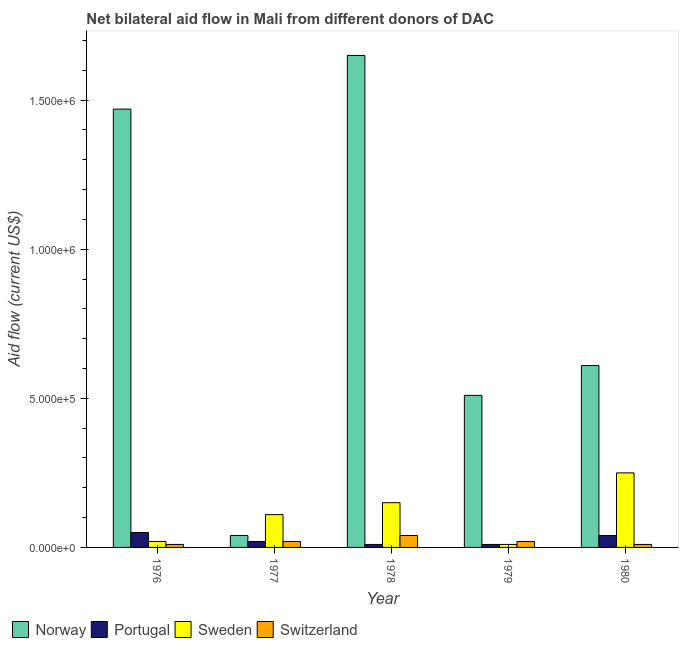How many different coloured bars are there?
Provide a succinct answer. 4. How many groups of bars are there?
Provide a short and direct response. 5. Are the number of bars per tick equal to the number of legend labels?
Provide a short and direct response. Yes. Are the number of bars on each tick of the X-axis equal?
Make the answer very short. Yes. What is the label of the 5th group of bars from the left?
Provide a short and direct response. 1980. In how many cases, is the number of bars for a given year not equal to the number of legend labels?
Offer a terse response. 0. What is the amount of aid given by norway in 1977?
Offer a very short reply. 4.00e+04. Across all years, what is the maximum amount of aid given by norway?
Give a very brief answer. 1.65e+06. Across all years, what is the minimum amount of aid given by switzerland?
Offer a very short reply. 10000. In which year was the amount of aid given by portugal maximum?
Make the answer very short. 1976. In which year was the amount of aid given by switzerland minimum?
Make the answer very short. 1976. What is the total amount of aid given by norway in the graph?
Your answer should be very brief. 4.28e+06. What is the difference between the amount of aid given by norway in 1979 and that in 1980?
Your answer should be compact. -1.00e+05. What is the difference between the amount of aid given by norway in 1976 and the amount of aid given by switzerland in 1977?
Make the answer very short. 1.43e+06. What is the average amount of aid given by portugal per year?
Provide a short and direct response. 2.60e+04. In the year 1979, what is the difference between the amount of aid given by norway and amount of aid given by portugal?
Make the answer very short. 0. In how many years, is the amount of aid given by norway greater than 400000 US$?
Offer a terse response. 4. What is the ratio of the amount of aid given by norway in 1977 to that in 1979?
Offer a terse response. 0.08. Is the amount of aid given by sweden in 1979 less than that in 1980?
Ensure brevity in your answer.  Yes. What is the difference between the highest and the lowest amount of aid given by portugal?
Make the answer very short. 4.00e+04. Is it the case that in every year, the sum of the amount of aid given by sweden and amount of aid given by norway is greater than the sum of amount of aid given by switzerland and amount of aid given by portugal?
Make the answer very short. No. What does the 1st bar from the left in 1980 represents?
Your answer should be very brief. Norway. What does the 1st bar from the right in 1977 represents?
Provide a short and direct response. Switzerland. How many bars are there?
Provide a succinct answer. 20. Are all the bars in the graph horizontal?
Make the answer very short. No. What is the difference between two consecutive major ticks on the Y-axis?
Provide a succinct answer. 5.00e+05. Are the values on the major ticks of Y-axis written in scientific E-notation?
Offer a very short reply. Yes. Does the graph contain grids?
Offer a very short reply. No. How many legend labels are there?
Offer a terse response. 4. What is the title of the graph?
Ensure brevity in your answer.  Net bilateral aid flow in Mali from different donors of DAC. What is the label or title of the Y-axis?
Provide a short and direct response. Aid flow (current US$). What is the Aid flow (current US$) in Norway in 1976?
Provide a short and direct response. 1.47e+06. What is the Aid flow (current US$) of Sweden in 1976?
Your answer should be very brief. 2.00e+04. What is the Aid flow (current US$) in Switzerland in 1976?
Your response must be concise. 10000. What is the Aid flow (current US$) in Norway in 1978?
Give a very brief answer. 1.65e+06. What is the Aid flow (current US$) in Portugal in 1978?
Offer a terse response. 10000. What is the Aid flow (current US$) of Sweden in 1978?
Provide a succinct answer. 1.50e+05. What is the Aid flow (current US$) in Norway in 1979?
Make the answer very short. 5.10e+05. What is the Aid flow (current US$) in Portugal in 1979?
Your answer should be very brief. 10000. What is the Aid flow (current US$) of Sweden in 1979?
Offer a terse response. 10000. What is the Aid flow (current US$) of Switzerland in 1979?
Make the answer very short. 2.00e+04. Across all years, what is the maximum Aid flow (current US$) in Norway?
Keep it short and to the point. 1.65e+06. Across all years, what is the maximum Aid flow (current US$) in Switzerland?
Give a very brief answer. 4.00e+04. Across all years, what is the minimum Aid flow (current US$) in Sweden?
Your answer should be compact. 10000. What is the total Aid flow (current US$) in Norway in the graph?
Give a very brief answer. 4.28e+06. What is the total Aid flow (current US$) of Sweden in the graph?
Your answer should be very brief. 5.40e+05. What is the difference between the Aid flow (current US$) in Norway in 1976 and that in 1977?
Offer a very short reply. 1.43e+06. What is the difference between the Aid flow (current US$) in Portugal in 1976 and that in 1977?
Your answer should be compact. 3.00e+04. What is the difference between the Aid flow (current US$) in Switzerland in 1976 and that in 1977?
Provide a succinct answer. -10000. What is the difference between the Aid flow (current US$) in Portugal in 1976 and that in 1978?
Provide a short and direct response. 4.00e+04. What is the difference between the Aid flow (current US$) of Sweden in 1976 and that in 1978?
Keep it short and to the point. -1.30e+05. What is the difference between the Aid flow (current US$) of Norway in 1976 and that in 1979?
Give a very brief answer. 9.60e+05. What is the difference between the Aid flow (current US$) in Portugal in 1976 and that in 1979?
Ensure brevity in your answer.  4.00e+04. What is the difference between the Aid flow (current US$) in Sweden in 1976 and that in 1979?
Provide a succinct answer. 10000. What is the difference between the Aid flow (current US$) of Norway in 1976 and that in 1980?
Your answer should be compact. 8.60e+05. What is the difference between the Aid flow (current US$) in Sweden in 1976 and that in 1980?
Keep it short and to the point. -2.30e+05. What is the difference between the Aid flow (current US$) in Norway in 1977 and that in 1978?
Your answer should be very brief. -1.61e+06. What is the difference between the Aid flow (current US$) of Portugal in 1977 and that in 1978?
Offer a terse response. 10000. What is the difference between the Aid flow (current US$) in Sweden in 1977 and that in 1978?
Your answer should be compact. -4.00e+04. What is the difference between the Aid flow (current US$) in Norway in 1977 and that in 1979?
Your answer should be very brief. -4.70e+05. What is the difference between the Aid flow (current US$) of Portugal in 1977 and that in 1979?
Keep it short and to the point. 10000. What is the difference between the Aid flow (current US$) of Sweden in 1977 and that in 1979?
Provide a short and direct response. 1.00e+05. What is the difference between the Aid flow (current US$) of Switzerland in 1977 and that in 1979?
Offer a very short reply. 0. What is the difference between the Aid flow (current US$) of Norway in 1977 and that in 1980?
Your answer should be very brief. -5.70e+05. What is the difference between the Aid flow (current US$) in Norway in 1978 and that in 1979?
Provide a succinct answer. 1.14e+06. What is the difference between the Aid flow (current US$) in Norway in 1978 and that in 1980?
Provide a short and direct response. 1.04e+06. What is the difference between the Aid flow (current US$) of Norway in 1979 and that in 1980?
Provide a succinct answer. -1.00e+05. What is the difference between the Aid flow (current US$) in Switzerland in 1979 and that in 1980?
Keep it short and to the point. 10000. What is the difference between the Aid flow (current US$) in Norway in 1976 and the Aid flow (current US$) in Portugal in 1977?
Ensure brevity in your answer.  1.45e+06. What is the difference between the Aid flow (current US$) in Norway in 1976 and the Aid flow (current US$) in Sweden in 1977?
Give a very brief answer. 1.36e+06. What is the difference between the Aid flow (current US$) of Norway in 1976 and the Aid flow (current US$) of Switzerland in 1977?
Your answer should be compact. 1.45e+06. What is the difference between the Aid flow (current US$) in Portugal in 1976 and the Aid flow (current US$) in Switzerland in 1977?
Give a very brief answer. 3.00e+04. What is the difference between the Aid flow (current US$) of Sweden in 1976 and the Aid flow (current US$) of Switzerland in 1977?
Provide a short and direct response. 0. What is the difference between the Aid flow (current US$) of Norway in 1976 and the Aid flow (current US$) of Portugal in 1978?
Offer a terse response. 1.46e+06. What is the difference between the Aid flow (current US$) of Norway in 1976 and the Aid flow (current US$) of Sweden in 1978?
Your answer should be compact. 1.32e+06. What is the difference between the Aid flow (current US$) in Norway in 1976 and the Aid flow (current US$) in Switzerland in 1978?
Your answer should be very brief. 1.43e+06. What is the difference between the Aid flow (current US$) in Norway in 1976 and the Aid flow (current US$) in Portugal in 1979?
Your answer should be compact. 1.46e+06. What is the difference between the Aid flow (current US$) in Norway in 1976 and the Aid flow (current US$) in Sweden in 1979?
Ensure brevity in your answer.  1.46e+06. What is the difference between the Aid flow (current US$) in Norway in 1976 and the Aid flow (current US$) in Switzerland in 1979?
Give a very brief answer. 1.45e+06. What is the difference between the Aid flow (current US$) of Sweden in 1976 and the Aid flow (current US$) of Switzerland in 1979?
Make the answer very short. 0. What is the difference between the Aid flow (current US$) in Norway in 1976 and the Aid flow (current US$) in Portugal in 1980?
Provide a succinct answer. 1.43e+06. What is the difference between the Aid flow (current US$) of Norway in 1976 and the Aid flow (current US$) of Sweden in 1980?
Provide a short and direct response. 1.22e+06. What is the difference between the Aid flow (current US$) of Norway in 1976 and the Aid flow (current US$) of Switzerland in 1980?
Provide a succinct answer. 1.46e+06. What is the difference between the Aid flow (current US$) in Portugal in 1976 and the Aid flow (current US$) in Switzerland in 1980?
Ensure brevity in your answer.  4.00e+04. What is the difference between the Aid flow (current US$) of Sweden in 1976 and the Aid flow (current US$) of Switzerland in 1980?
Your answer should be compact. 10000. What is the difference between the Aid flow (current US$) of Norway in 1977 and the Aid flow (current US$) of Portugal in 1978?
Your answer should be compact. 3.00e+04. What is the difference between the Aid flow (current US$) in Norway in 1977 and the Aid flow (current US$) in Switzerland in 1978?
Ensure brevity in your answer.  0. What is the difference between the Aid flow (current US$) in Portugal in 1977 and the Aid flow (current US$) in Sweden in 1978?
Provide a short and direct response. -1.30e+05. What is the difference between the Aid flow (current US$) of Sweden in 1977 and the Aid flow (current US$) of Switzerland in 1978?
Provide a succinct answer. 7.00e+04. What is the difference between the Aid flow (current US$) of Norway in 1977 and the Aid flow (current US$) of Sweden in 1979?
Offer a very short reply. 3.00e+04. What is the difference between the Aid flow (current US$) in Portugal in 1977 and the Aid flow (current US$) in Sweden in 1979?
Offer a very short reply. 10000. What is the difference between the Aid flow (current US$) of Portugal in 1977 and the Aid flow (current US$) of Switzerland in 1979?
Your answer should be very brief. 0. What is the difference between the Aid flow (current US$) of Sweden in 1977 and the Aid flow (current US$) of Switzerland in 1979?
Your answer should be very brief. 9.00e+04. What is the difference between the Aid flow (current US$) in Norway in 1977 and the Aid flow (current US$) in Portugal in 1980?
Keep it short and to the point. 0. What is the difference between the Aid flow (current US$) of Norway in 1977 and the Aid flow (current US$) of Switzerland in 1980?
Offer a terse response. 3.00e+04. What is the difference between the Aid flow (current US$) of Portugal in 1977 and the Aid flow (current US$) of Sweden in 1980?
Your answer should be very brief. -2.30e+05. What is the difference between the Aid flow (current US$) in Portugal in 1977 and the Aid flow (current US$) in Switzerland in 1980?
Keep it short and to the point. 10000. What is the difference between the Aid flow (current US$) in Norway in 1978 and the Aid flow (current US$) in Portugal in 1979?
Ensure brevity in your answer.  1.64e+06. What is the difference between the Aid flow (current US$) in Norway in 1978 and the Aid flow (current US$) in Sweden in 1979?
Provide a succinct answer. 1.64e+06. What is the difference between the Aid flow (current US$) in Norway in 1978 and the Aid flow (current US$) in Switzerland in 1979?
Your answer should be very brief. 1.63e+06. What is the difference between the Aid flow (current US$) of Portugal in 1978 and the Aid flow (current US$) of Sweden in 1979?
Make the answer very short. 0. What is the difference between the Aid flow (current US$) in Portugal in 1978 and the Aid flow (current US$) in Switzerland in 1979?
Ensure brevity in your answer.  -10000. What is the difference between the Aid flow (current US$) in Norway in 1978 and the Aid flow (current US$) in Portugal in 1980?
Provide a succinct answer. 1.61e+06. What is the difference between the Aid flow (current US$) in Norway in 1978 and the Aid flow (current US$) in Sweden in 1980?
Offer a very short reply. 1.40e+06. What is the difference between the Aid flow (current US$) of Norway in 1978 and the Aid flow (current US$) of Switzerland in 1980?
Give a very brief answer. 1.64e+06. What is the difference between the Aid flow (current US$) of Sweden in 1978 and the Aid flow (current US$) of Switzerland in 1980?
Give a very brief answer. 1.40e+05. What is the difference between the Aid flow (current US$) in Norway in 1979 and the Aid flow (current US$) in Switzerland in 1980?
Your answer should be very brief. 5.00e+05. What is the difference between the Aid flow (current US$) in Portugal in 1979 and the Aid flow (current US$) in Sweden in 1980?
Offer a terse response. -2.40e+05. What is the difference between the Aid flow (current US$) in Portugal in 1979 and the Aid flow (current US$) in Switzerland in 1980?
Your answer should be compact. 0. What is the difference between the Aid flow (current US$) of Sweden in 1979 and the Aid flow (current US$) of Switzerland in 1980?
Offer a very short reply. 0. What is the average Aid flow (current US$) in Norway per year?
Give a very brief answer. 8.56e+05. What is the average Aid flow (current US$) in Portugal per year?
Your answer should be very brief. 2.60e+04. What is the average Aid flow (current US$) of Sweden per year?
Your answer should be very brief. 1.08e+05. In the year 1976, what is the difference between the Aid flow (current US$) of Norway and Aid flow (current US$) of Portugal?
Offer a very short reply. 1.42e+06. In the year 1976, what is the difference between the Aid flow (current US$) in Norway and Aid flow (current US$) in Sweden?
Keep it short and to the point. 1.45e+06. In the year 1976, what is the difference between the Aid flow (current US$) of Norway and Aid flow (current US$) of Switzerland?
Offer a terse response. 1.46e+06. In the year 1976, what is the difference between the Aid flow (current US$) of Portugal and Aid flow (current US$) of Sweden?
Keep it short and to the point. 3.00e+04. In the year 1976, what is the difference between the Aid flow (current US$) in Sweden and Aid flow (current US$) in Switzerland?
Give a very brief answer. 10000. In the year 1977, what is the difference between the Aid flow (current US$) in Norway and Aid flow (current US$) in Portugal?
Provide a succinct answer. 2.00e+04. In the year 1977, what is the difference between the Aid flow (current US$) in Norway and Aid flow (current US$) in Sweden?
Make the answer very short. -7.00e+04. In the year 1977, what is the difference between the Aid flow (current US$) in Portugal and Aid flow (current US$) in Switzerland?
Provide a succinct answer. 0. In the year 1977, what is the difference between the Aid flow (current US$) in Sweden and Aid flow (current US$) in Switzerland?
Your response must be concise. 9.00e+04. In the year 1978, what is the difference between the Aid flow (current US$) of Norway and Aid flow (current US$) of Portugal?
Your response must be concise. 1.64e+06. In the year 1978, what is the difference between the Aid flow (current US$) of Norway and Aid flow (current US$) of Sweden?
Your response must be concise. 1.50e+06. In the year 1978, what is the difference between the Aid flow (current US$) in Norway and Aid flow (current US$) in Switzerland?
Offer a terse response. 1.61e+06. In the year 1978, what is the difference between the Aid flow (current US$) of Portugal and Aid flow (current US$) of Sweden?
Ensure brevity in your answer.  -1.40e+05. In the year 1979, what is the difference between the Aid flow (current US$) of Norway and Aid flow (current US$) of Sweden?
Provide a succinct answer. 5.00e+05. In the year 1980, what is the difference between the Aid flow (current US$) in Norway and Aid flow (current US$) in Portugal?
Keep it short and to the point. 5.70e+05. In the year 1980, what is the difference between the Aid flow (current US$) in Portugal and Aid flow (current US$) in Switzerland?
Your answer should be very brief. 3.00e+04. In the year 1980, what is the difference between the Aid flow (current US$) in Sweden and Aid flow (current US$) in Switzerland?
Ensure brevity in your answer.  2.40e+05. What is the ratio of the Aid flow (current US$) in Norway in 1976 to that in 1977?
Provide a short and direct response. 36.75. What is the ratio of the Aid flow (current US$) in Portugal in 1976 to that in 1977?
Give a very brief answer. 2.5. What is the ratio of the Aid flow (current US$) in Sweden in 1976 to that in 1977?
Ensure brevity in your answer.  0.18. What is the ratio of the Aid flow (current US$) of Switzerland in 1976 to that in 1977?
Ensure brevity in your answer.  0.5. What is the ratio of the Aid flow (current US$) of Norway in 1976 to that in 1978?
Your response must be concise. 0.89. What is the ratio of the Aid flow (current US$) of Portugal in 1976 to that in 1978?
Make the answer very short. 5. What is the ratio of the Aid flow (current US$) of Sweden in 1976 to that in 1978?
Ensure brevity in your answer.  0.13. What is the ratio of the Aid flow (current US$) in Switzerland in 1976 to that in 1978?
Make the answer very short. 0.25. What is the ratio of the Aid flow (current US$) of Norway in 1976 to that in 1979?
Keep it short and to the point. 2.88. What is the ratio of the Aid flow (current US$) of Portugal in 1976 to that in 1979?
Make the answer very short. 5. What is the ratio of the Aid flow (current US$) of Switzerland in 1976 to that in 1979?
Provide a succinct answer. 0.5. What is the ratio of the Aid flow (current US$) of Norway in 1976 to that in 1980?
Ensure brevity in your answer.  2.41. What is the ratio of the Aid flow (current US$) in Sweden in 1976 to that in 1980?
Make the answer very short. 0.08. What is the ratio of the Aid flow (current US$) in Switzerland in 1976 to that in 1980?
Offer a terse response. 1. What is the ratio of the Aid flow (current US$) in Norway in 1977 to that in 1978?
Offer a very short reply. 0.02. What is the ratio of the Aid flow (current US$) in Portugal in 1977 to that in 1978?
Provide a succinct answer. 2. What is the ratio of the Aid flow (current US$) in Sweden in 1977 to that in 1978?
Your answer should be compact. 0.73. What is the ratio of the Aid flow (current US$) of Norway in 1977 to that in 1979?
Provide a short and direct response. 0.08. What is the ratio of the Aid flow (current US$) in Portugal in 1977 to that in 1979?
Make the answer very short. 2. What is the ratio of the Aid flow (current US$) of Switzerland in 1977 to that in 1979?
Your response must be concise. 1. What is the ratio of the Aid flow (current US$) in Norway in 1977 to that in 1980?
Ensure brevity in your answer.  0.07. What is the ratio of the Aid flow (current US$) in Portugal in 1977 to that in 1980?
Provide a short and direct response. 0.5. What is the ratio of the Aid flow (current US$) of Sweden in 1977 to that in 1980?
Your answer should be compact. 0.44. What is the ratio of the Aid flow (current US$) in Switzerland in 1977 to that in 1980?
Offer a terse response. 2. What is the ratio of the Aid flow (current US$) of Norway in 1978 to that in 1979?
Keep it short and to the point. 3.24. What is the ratio of the Aid flow (current US$) of Portugal in 1978 to that in 1979?
Ensure brevity in your answer.  1. What is the ratio of the Aid flow (current US$) of Sweden in 1978 to that in 1979?
Your answer should be compact. 15. What is the ratio of the Aid flow (current US$) of Norway in 1978 to that in 1980?
Provide a short and direct response. 2.7. What is the ratio of the Aid flow (current US$) in Portugal in 1978 to that in 1980?
Make the answer very short. 0.25. What is the ratio of the Aid flow (current US$) of Sweden in 1978 to that in 1980?
Offer a terse response. 0.6. What is the ratio of the Aid flow (current US$) in Switzerland in 1978 to that in 1980?
Offer a very short reply. 4. What is the ratio of the Aid flow (current US$) of Norway in 1979 to that in 1980?
Provide a short and direct response. 0.84. What is the ratio of the Aid flow (current US$) of Portugal in 1979 to that in 1980?
Your response must be concise. 0.25. What is the difference between the highest and the second highest Aid flow (current US$) in Norway?
Offer a very short reply. 1.80e+05. What is the difference between the highest and the lowest Aid flow (current US$) of Norway?
Provide a succinct answer. 1.61e+06. What is the difference between the highest and the lowest Aid flow (current US$) of Switzerland?
Your answer should be compact. 3.00e+04. 